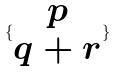<formula> <loc_0><loc_0><loc_500><loc_500>\{ \begin{matrix} p \\ q + r \end{matrix} \}</formula> 